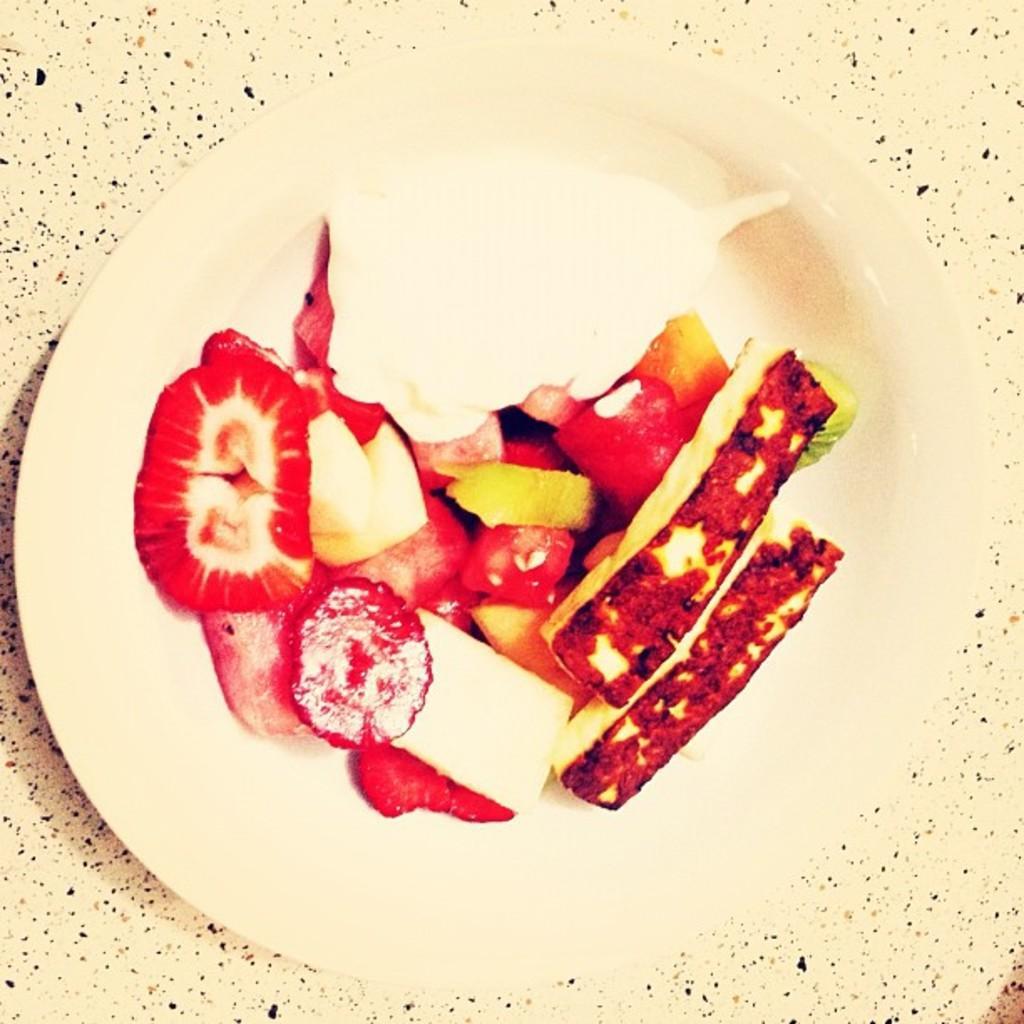Please provide a concise description of this image. We can see plate with food on the surface. 